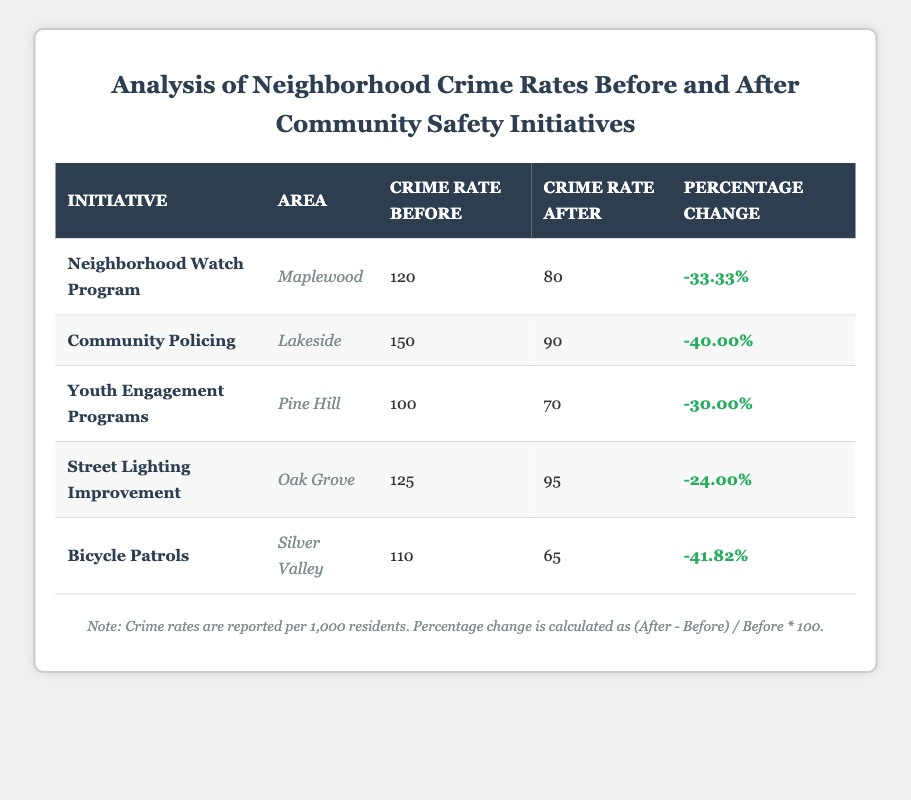What is the crime rate in Maplewood before the Neighborhood Watch Program? The table shows that the crime rate before the Neighborhood Watch Program in Maplewood is 120.
Answer: 120 What is the percentage change in crime rate for the Community Policing initiative in Lakeside? The table indicates that the percentage change for the Community Policing initiative is -40.00%.
Answer: -40.00% Which neighborhood experienced the largest decrease in crime rate percentage after the safety initiative? To find this, we look for the highest negative percentage change: Bicycle Patrols in Silver Valley had -41.82%, which is the largest decrease.
Answer: Silver Valley Is the crime rate after the Youth Engagement Programs in Pine Hill lower than 75? Referring to the table, the crime rate after the Youth Engagement Programs in Pine Hill is 70, which is lower than 75.
Answer: Yes What is the average crime rate before the initiatives across all neighborhoods? We total the crime rates before the initiatives: 120 + 150 + 100 + 125 + 110 = 605. There are 5 neighborhoods, so the average is 605 divided by 5, which results in 121.
Answer: 121 How many neighborhoods had crime rates reduced by more than 30%? Checking the percentage changes, we see that Neighborhood Watch Program, Community Policing, Youth Engagement Programs, and Bicycle Patrols all had reductions greater than 30%. That gives us four neighborhoods overall.
Answer: 4 What is the difference in crime rates before and after the Street Lighting Improvement initiative in Oak Grove? The crime rate before was 125, and after it was 95. The difference is calculated as 125 - 95 = 30.
Answer: 30 Was the crime rate after the Neighborhood Watch Program higher than that after the Street Lighting Improvement? The crime rate after the Neighborhood Watch Program was 80, and after the Street Lighting Improvement, it was 95. Since 80 is less than 95, the statement is false.
Answer: No What is the total crime rate before the initiatives for neighborhoods that implemented crime reduction strategies? Adding the crime rates before for each initiative: 120 (Maplewood) + 150 (Lakeside) + 100 (Pine Hill) + 125 (Oak Grove) + 110 (Silver Valley) equals 605.
Answer: 605 